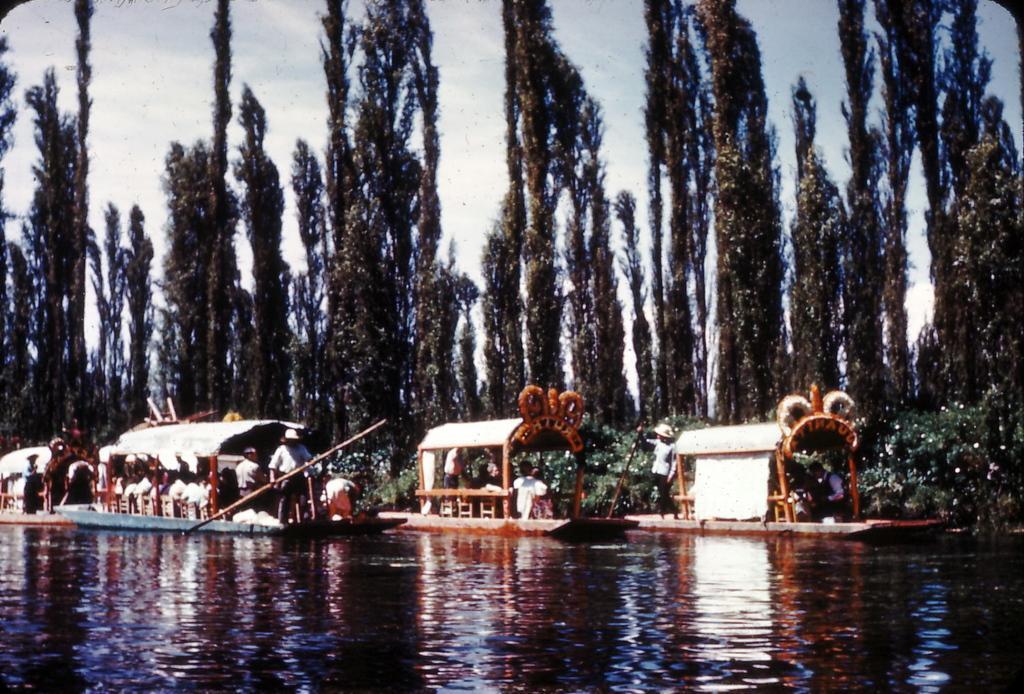Describe this image in one or two sentences. In this picture I can see boats on the water. On the boats I can see people. This man is holding an object. In the background I can see trees and the sky. 